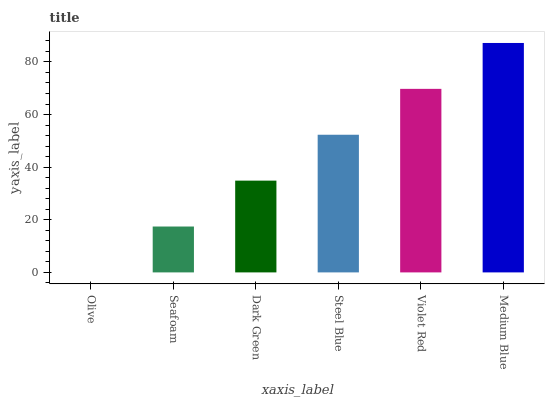Is Olive the minimum?
Answer yes or no. Yes. Is Medium Blue the maximum?
Answer yes or no. Yes. Is Seafoam the minimum?
Answer yes or no. No. Is Seafoam the maximum?
Answer yes or no. No. Is Seafoam greater than Olive?
Answer yes or no. Yes. Is Olive less than Seafoam?
Answer yes or no. Yes. Is Olive greater than Seafoam?
Answer yes or no. No. Is Seafoam less than Olive?
Answer yes or no. No. Is Steel Blue the high median?
Answer yes or no. Yes. Is Dark Green the low median?
Answer yes or no. Yes. Is Medium Blue the high median?
Answer yes or no. No. Is Violet Red the low median?
Answer yes or no. No. 